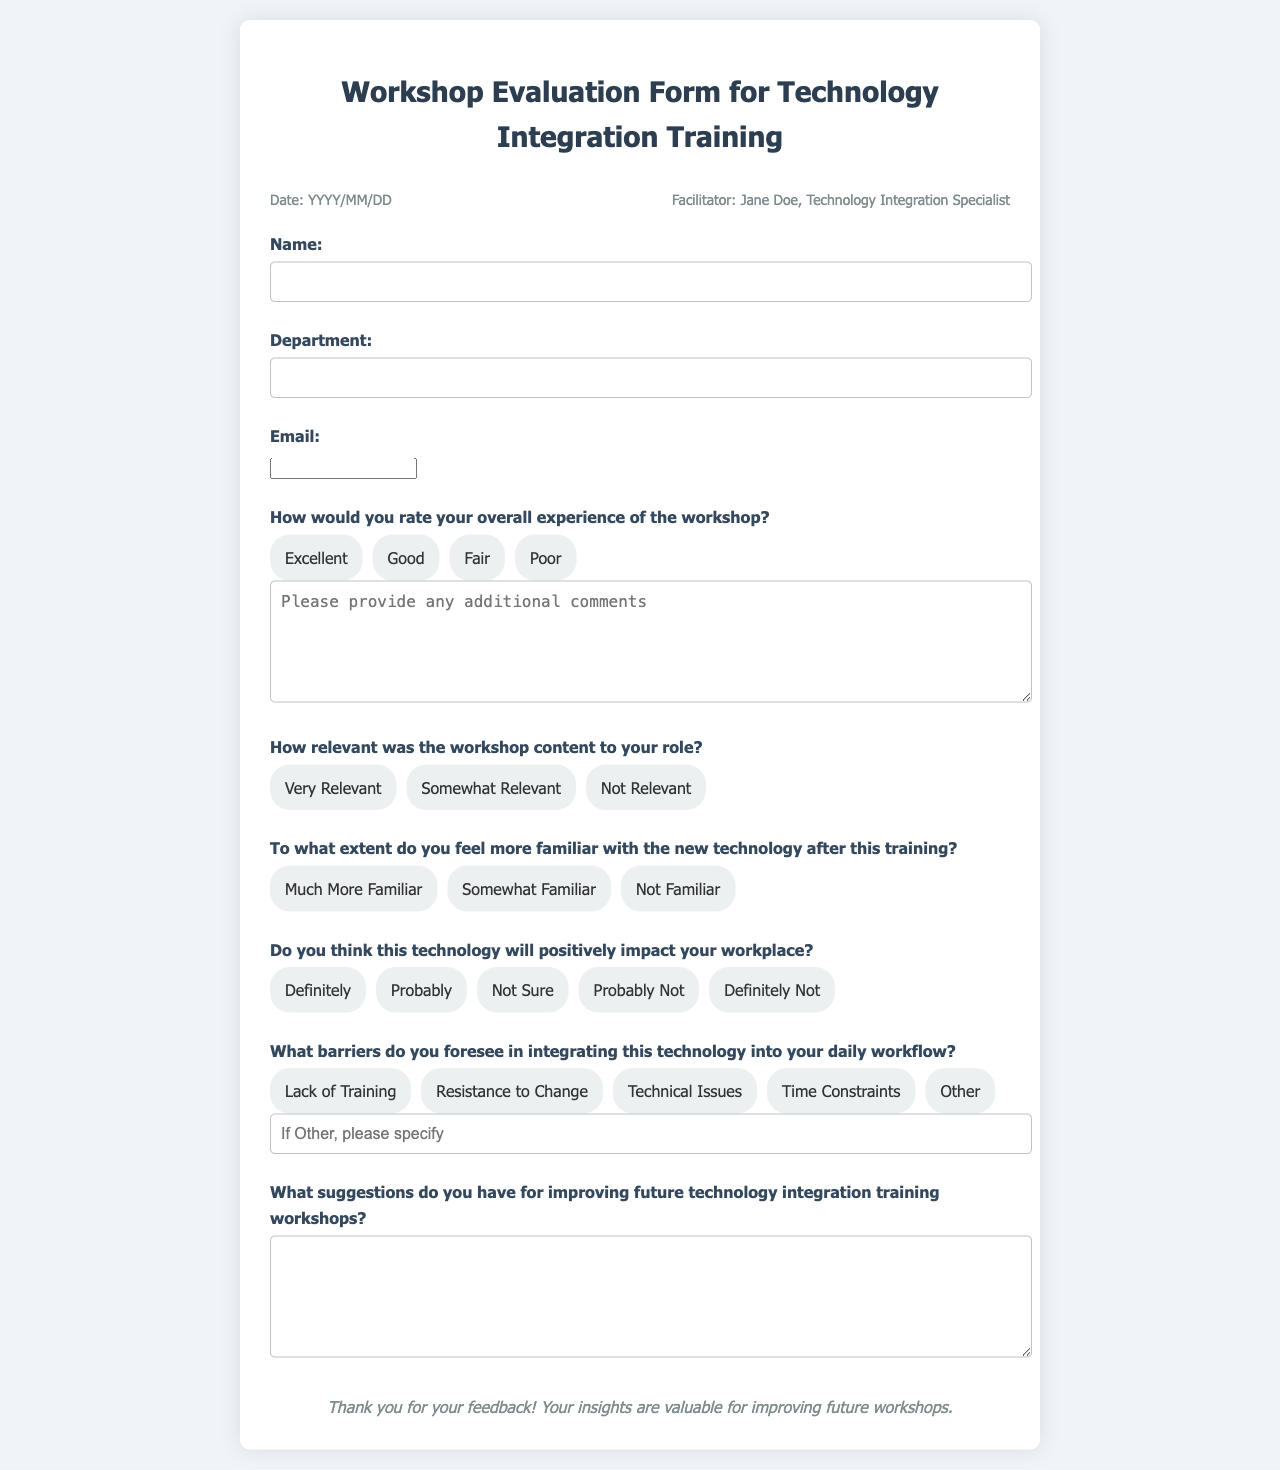what is the title of the document? The title of the document is indicated at the top of the page.
Answer: Workshop Evaluation Form for Technology Integration Training who is the facilitator of the workshop? The facilitator's name is provided in the header information section of the document.
Answer: Jane Doe what date is mentioned in the document? The document has a placeholder for the date in the header information section.
Answer: YYYY/MM/DD how many options are provided for rating overall experience? The total number of options is listed under the overall experience section of the form.
Answer: 4 what is one of the barriers listed for integrating technology? One of the barriers is found in the respective section asking for foreseeable barriers.
Answer: Resistance to Change what suggestion does the document ask for? The document asks for suggestions regarding the improvement of future technology integration training workshops.
Answer: Improving future technology integration training workshops how is the layout of the header organized? The layout of the header is organized in a way that includes the date and facilitator information side by side.
Answer: Side by side what feedback does the document express at the end? The document provides a thank you message to participants at the end of the form.
Answer: Thank you for your feedback! 